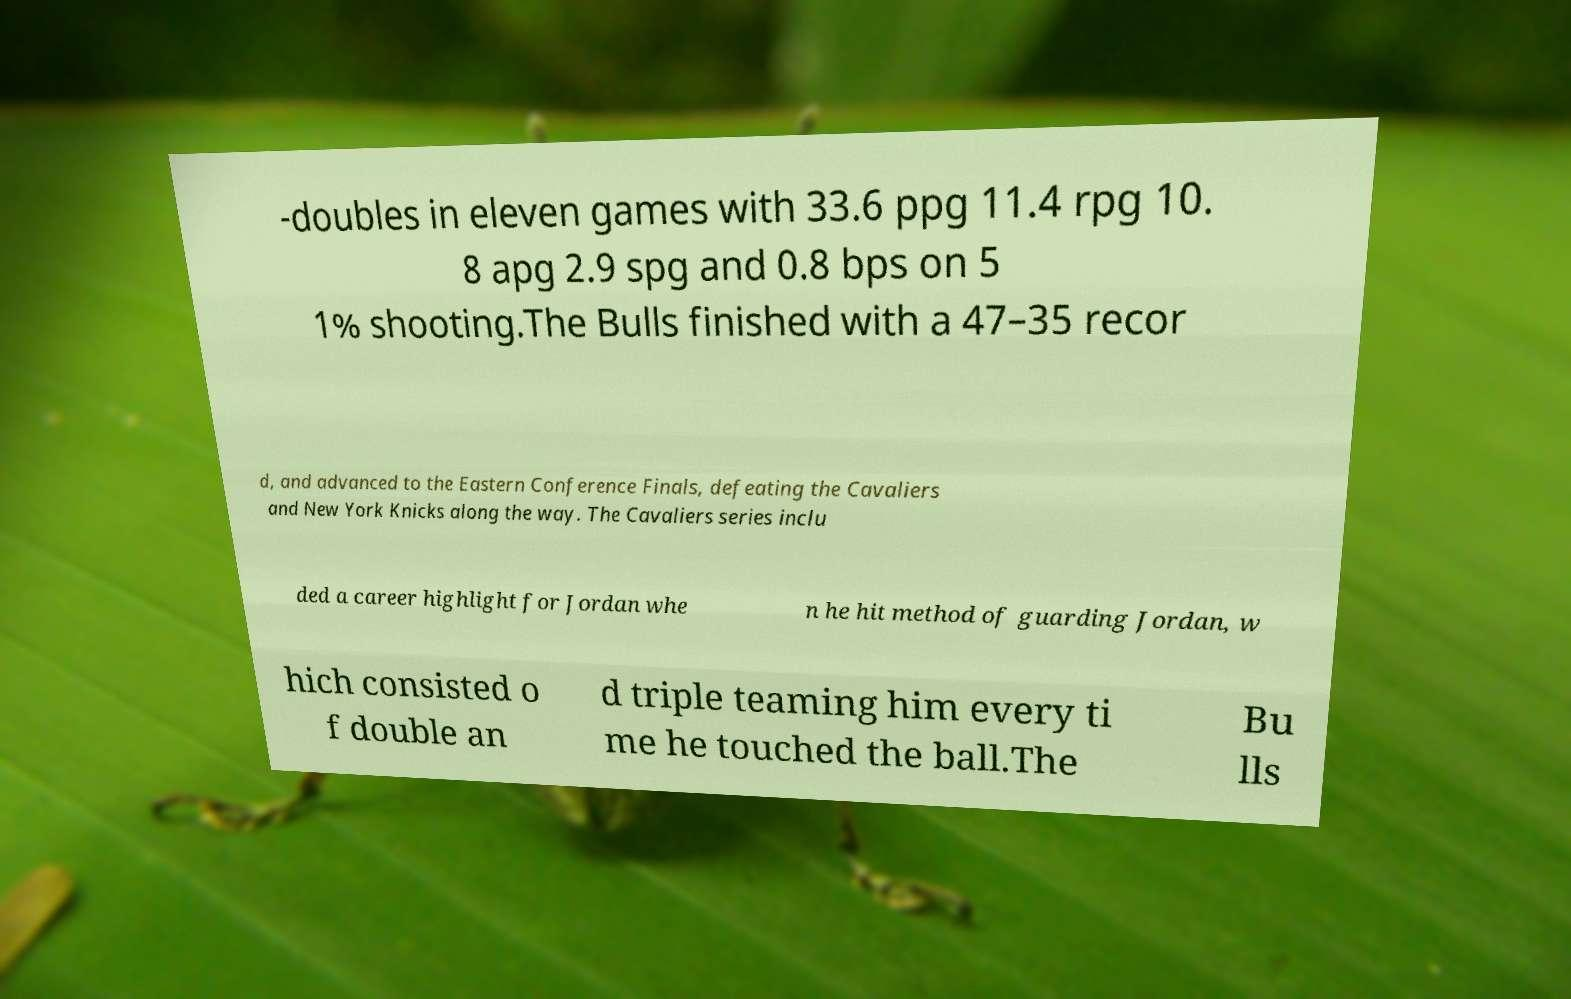Can you accurately transcribe the text from the provided image for me? -doubles in eleven games with 33.6 ppg 11.4 rpg 10. 8 apg 2.9 spg and 0.8 bps on 5 1% shooting.The Bulls finished with a 47–35 recor d, and advanced to the Eastern Conference Finals, defeating the Cavaliers and New York Knicks along the way. The Cavaliers series inclu ded a career highlight for Jordan whe n he hit method of guarding Jordan, w hich consisted o f double an d triple teaming him every ti me he touched the ball.The Bu lls 